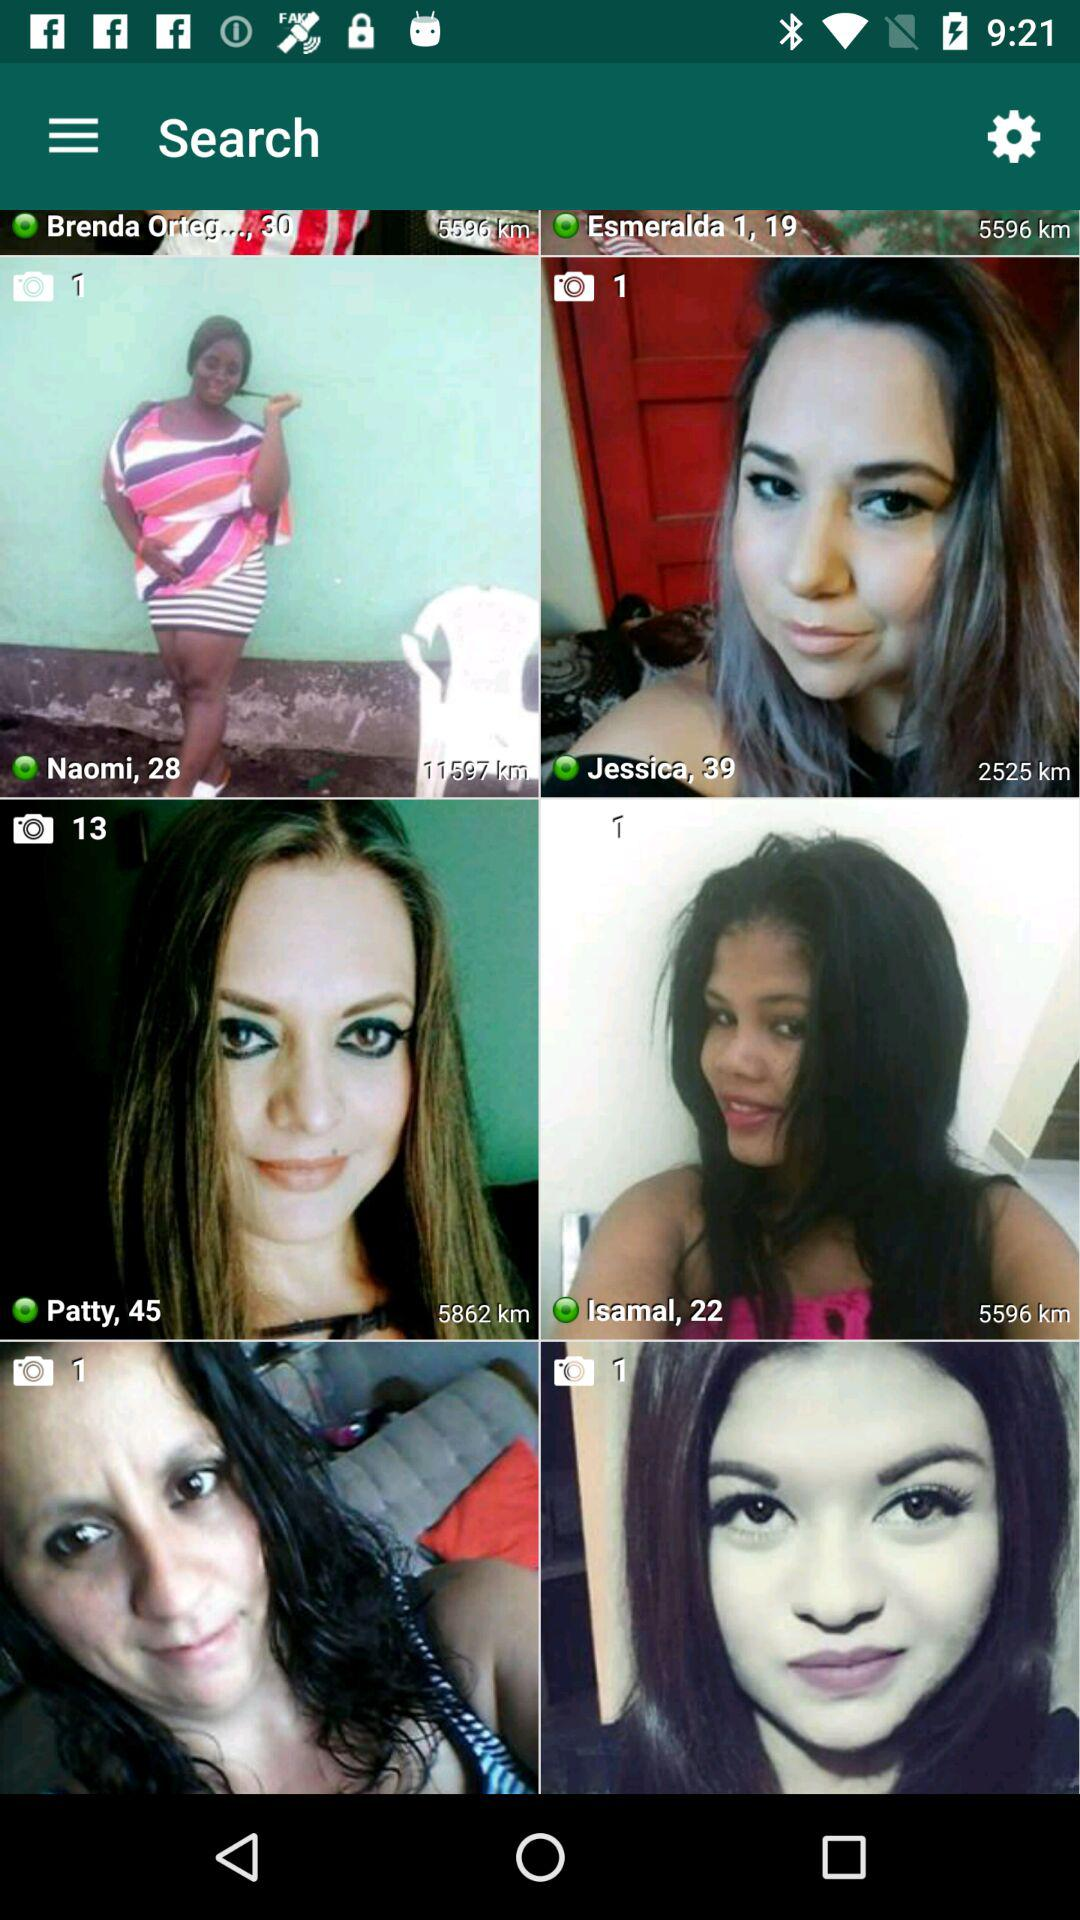What is the displayed distance of Isamal? The displayed distance of Isamal is 5596 km. 